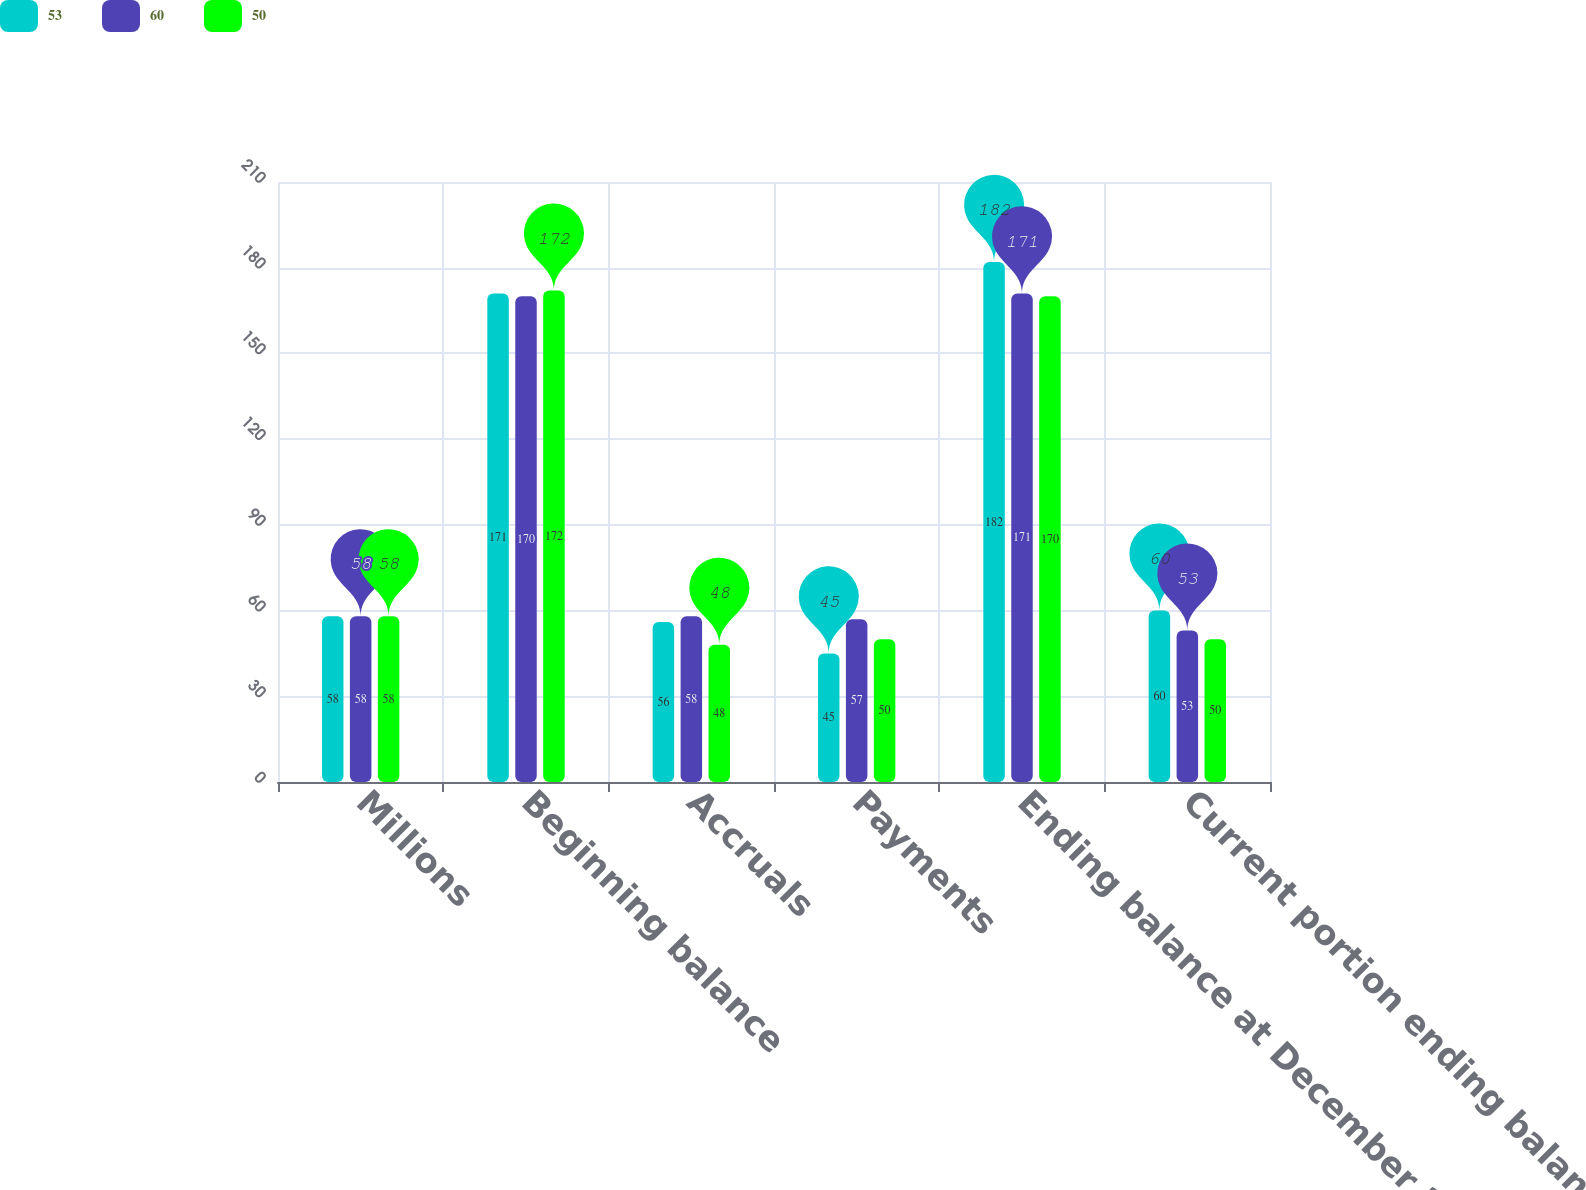Convert chart to OTSL. <chart><loc_0><loc_0><loc_500><loc_500><stacked_bar_chart><ecel><fcel>Millions<fcel>Beginning balance<fcel>Accruals<fcel>Payments<fcel>Ending balance at December 31<fcel>Current portion ending balance<nl><fcel>53<fcel>58<fcel>171<fcel>56<fcel>45<fcel>182<fcel>60<nl><fcel>60<fcel>58<fcel>170<fcel>58<fcel>57<fcel>171<fcel>53<nl><fcel>50<fcel>58<fcel>172<fcel>48<fcel>50<fcel>170<fcel>50<nl></chart> 